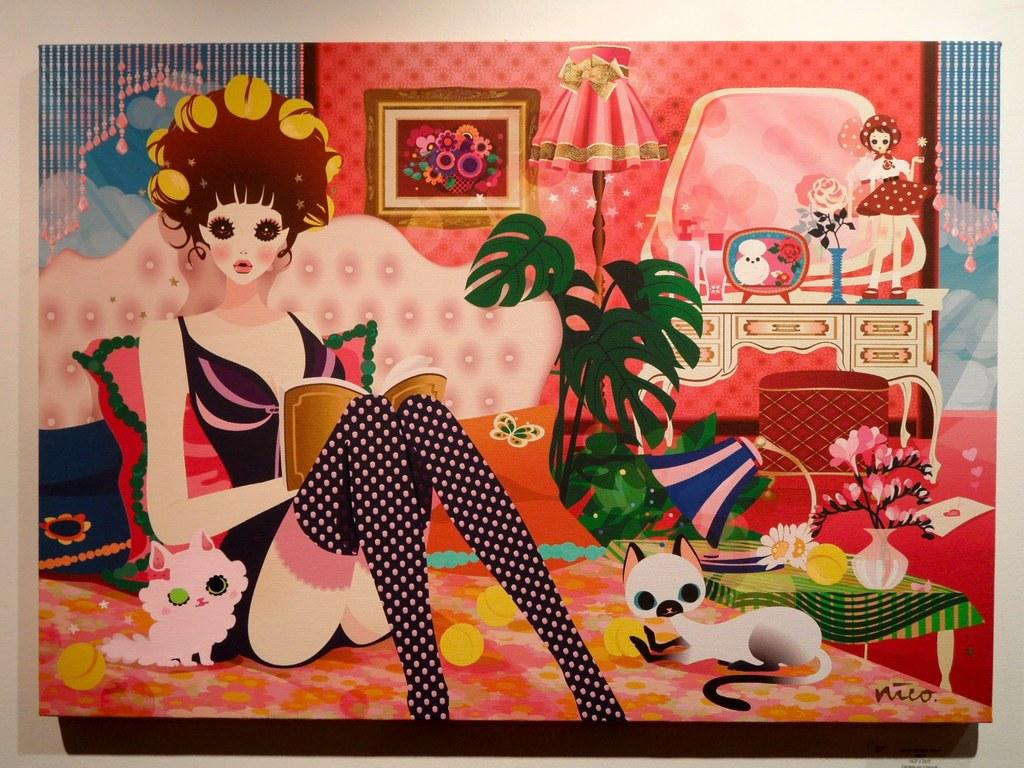What type of image is displayed in the photo frame in the image? The photo frame features a cartoon in the image. Can you describe the main character in the cartoon? The cartoon features a girl. What is another object visible in the image? There is a lamp in the image. What can be found in the room that might be used for play? Toys are present in the image. What type of furniture is in the room? There is a bed in the image. What animal is visible in the image? A cat is visible in the image. What type of decorative item is present in the room? There is a flower vase in the image. What color is the wall in the room? The wall is white in color. Where is the basket of corn located in the image? There is no basket of corn present in the image. What type of coal is used to heat the room in the image? There is no coal present in the image, and the room's heating method is not mentioned. 